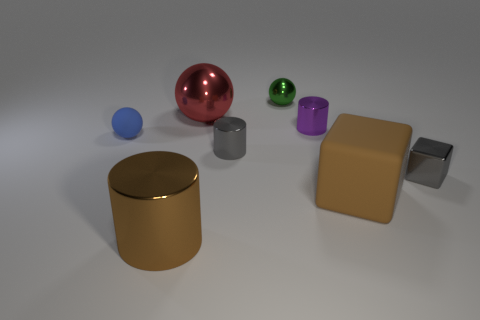Add 1 big red metal spheres. How many objects exist? 9 Subtract all balls. How many objects are left? 5 Add 3 gray things. How many gray things are left? 5 Add 8 brown cylinders. How many brown cylinders exist? 9 Subtract 0 red cylinders. How many objects are left? 8 Subtract all tiny blue balls. Subtract all rubber things. How many objects are left? 5 